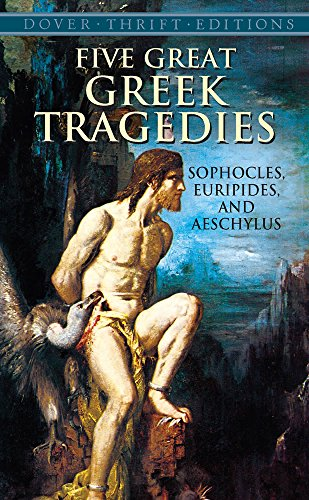Is this a recipe book? No, this is not a recipe book. It is a collection of Greek tragedies, a genre far removed from culinary arts. 